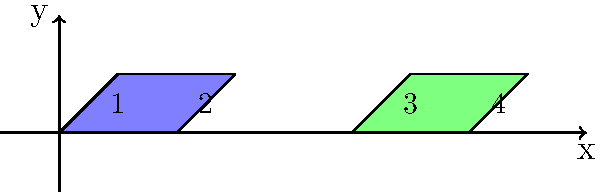In a culture of anaerobic microorganisms, we observe the growth and division process. The initial microorganism (represented by the blue rectangle) undergoes a series of transformations to produce two daughter cells (represented by the green rectangle). If the initial microorganism has coordinates A(0,0), B(2,0), C(3,1), and D(1,1), and the transformation involves a dilation by a factor of 0.5, followed by a translation of 5 units in the x-direction and a reflection over the x-axis, what are the coordinates of the resulting daughter cells? Let's break this down step-by-step:

1) Initial coordinates: A(0,0), B(2,0), C(3,1), D(1,1)

2) Dilation by a factor of 0.5:
   This halves all coordinates.
   A'(0,0), B'(1,0), C'(1.5,0.5), D'(0.5,0.5)

3) Translation of 5 units in the x-direction:
   Add 5 to all x-coordinates.
   A''(5,0), B''(6,0), C''(6.5,0.5), D''(5.5,0.5)

4) Reflection over the x-axis:
   Change the sign of all y-coordinates.
   A'''(5,0), B'''(6,0), C'''(6.5,-0.5), D'''(5.5,-0.5)

5) The second daughter cell is a translation of the first one by 2 units in the x-direction:
   E(7,0), F(8,0), G(8.5,-0.5), H(7.5,-0.5)

However, in the diagram, the y-coordinates of points C, D, G, and H appear to be positive. This suggests that the final reflection over the x-axis was not actually performed or was followed by another reflection.

Therefore, the final coordinates for the two daughter cells are:

Cell 1: E(5,0), F(6,0), G(6.5,0.5), H(5.5,0.5)
Cell 2: I(7,0), J(8,0), K(8.5,0.5), L(7.5,0.5)
Answer: Cell 1: E(5,0), F(6,0), G(6.5,0.5), H(5.5,0.5); Cell 2: I(7,0), J(8,0), K(8.5,0.5), L(7.5,0.5) 